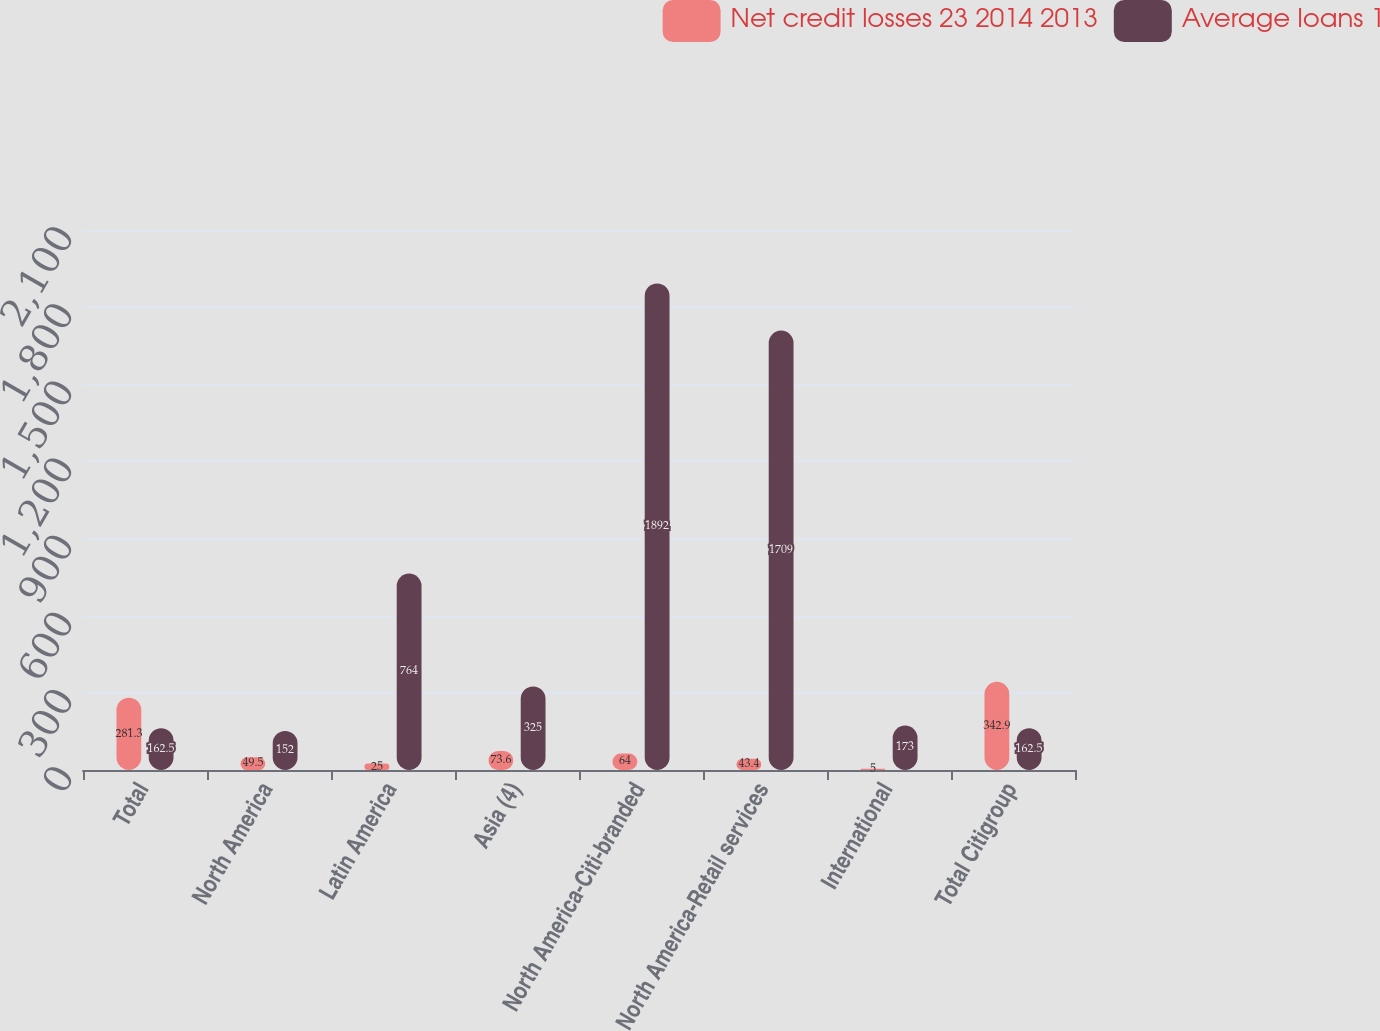<chart> <loc_0><loc_0><loc_500><loc_500><stacked_bar_chart><ecel><fcel>Total<fcel>North America<fcel>Latin America<fcel>Asia (4)<fcel>North America-Citi-branded<fcel>North America-Retail services<fcel>International<fcel>Total Citigroup<nl><fcel>Net credit losses 23 2014 2013<fcel>281.3<fcel>49.5<fcel>25<fcel>73.6<fcel>64<fcel>43.4<fcel>5<fcel>342.9<nl><fcel>Average loans 1<fcel>162.5<fcel>152<fcel>764<fcel>325<fcel>1892<fcel>1709<fcel>173<fcel>162.5<nl></chart> 